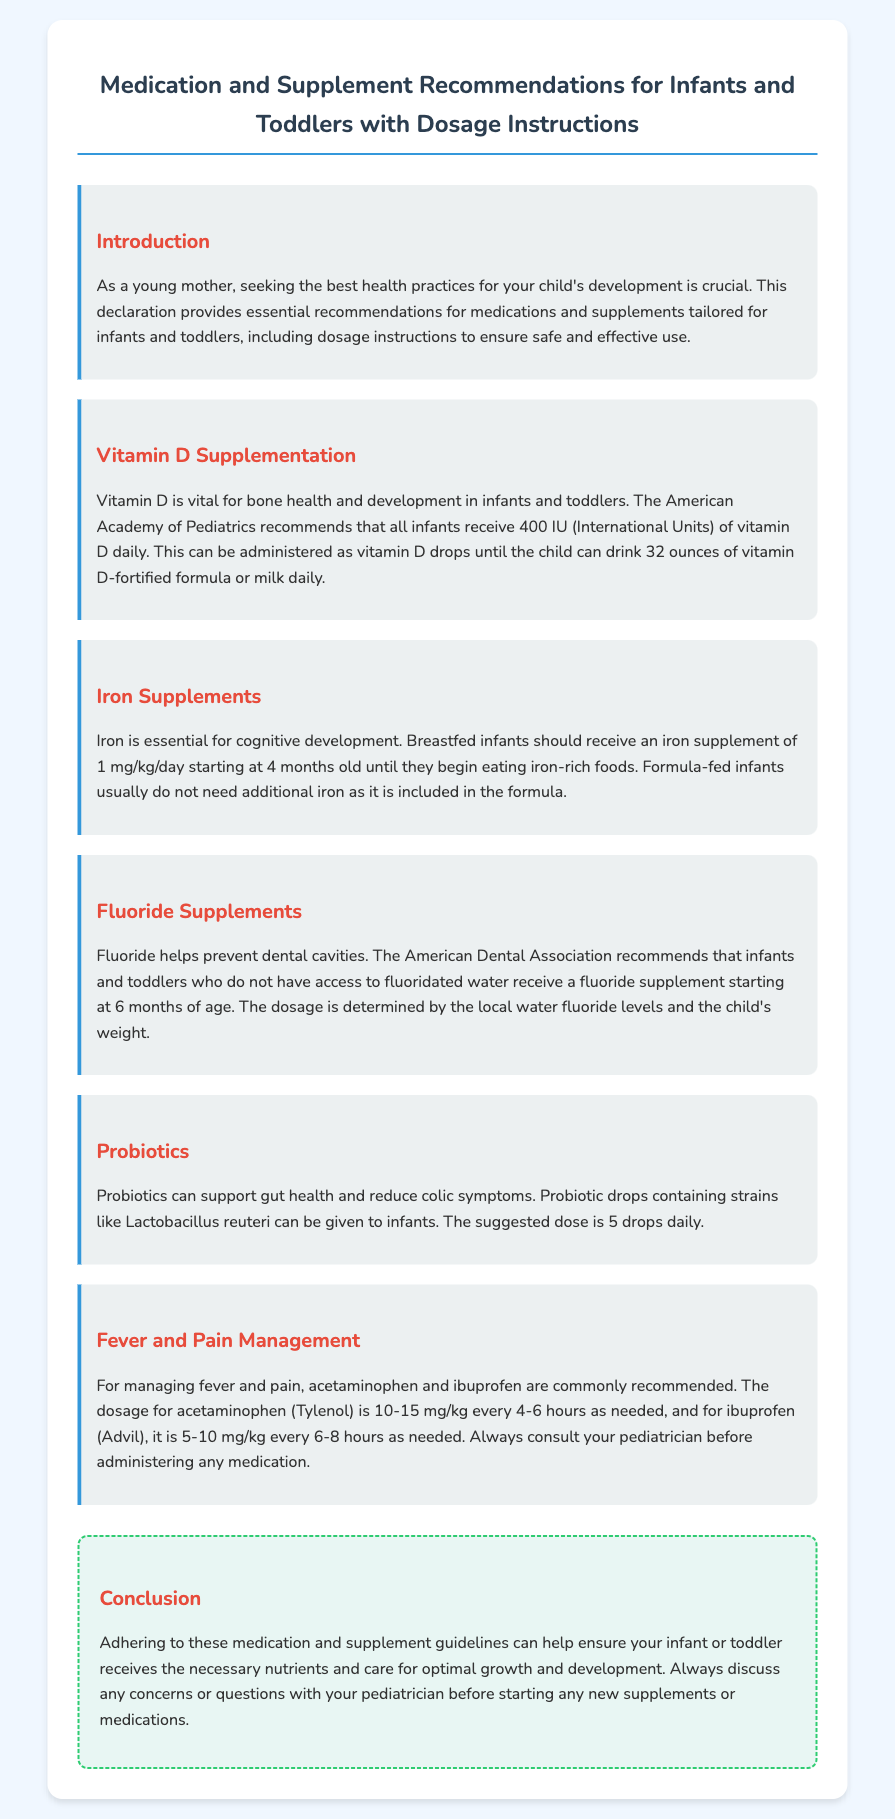What is the recommended daily dosage of vitamin D for infants? The document states that the American Academy of Pediatrics recommends that all infants receive 400 IU (International Units) of vitamin D daily.
Answer: 400 IU At what age should infants begin receiving fluoride supplements? The document mentions that the American Dental Association recommends fluoride supplements starting at 6 months of age.
Answer: 6 months What is the suggested dosage for iron supplements in breastfed infants? It is mentioned that breastfed infants should receive an iron supplement of 1 mg/kg/day starting at 4 months old.
Answer: 1 mg/kg/day How often can acetaminophen be administered to infants? According to the document, acetaminophen can be administered every 4-6 hours as needed.
Answer: Every 4-6 hours What is the primary benefit of probiotics mentioned in the document? The document states that probiotics can support gut health and reduce colic symptoms.
Answer: Gut health and colic symptoms Which vitamin is vital for bone health in infants? The document highlights that vitamin D is vital for bone health and development in infants and toddlers.
Answer: Vitamin D What is the suggested dose of probiotic drops for infants? It states that the suggested dose of probiotic drops containing strains like Lactobacillus reuteri is 5 drops daily.
Answer: 5 drops daily What should always be done before administering medications to children? The document emphasizes to always consult your pediatrician before administering any medication.
Answer: Consult your pediatrician 